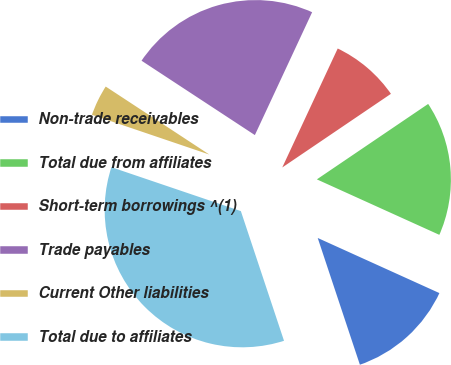Convert chart to OTSL. <chart><loc_0><loc_0><loc_500><loc_500><pie_chart><fcel>Non-trade receivables<fcel>Total due from affiliates<fcel>Short-term borrowings ^(1)<fcel>Trade payables<fcel>Current Other liabilities<fcel>Total due to affiliates<nl><fcel>13.12%<fcel>16.25%<fcel>8.58%<fcel>22.7%<fcel>4.04%<fcel>35.32%<nl></chart> 